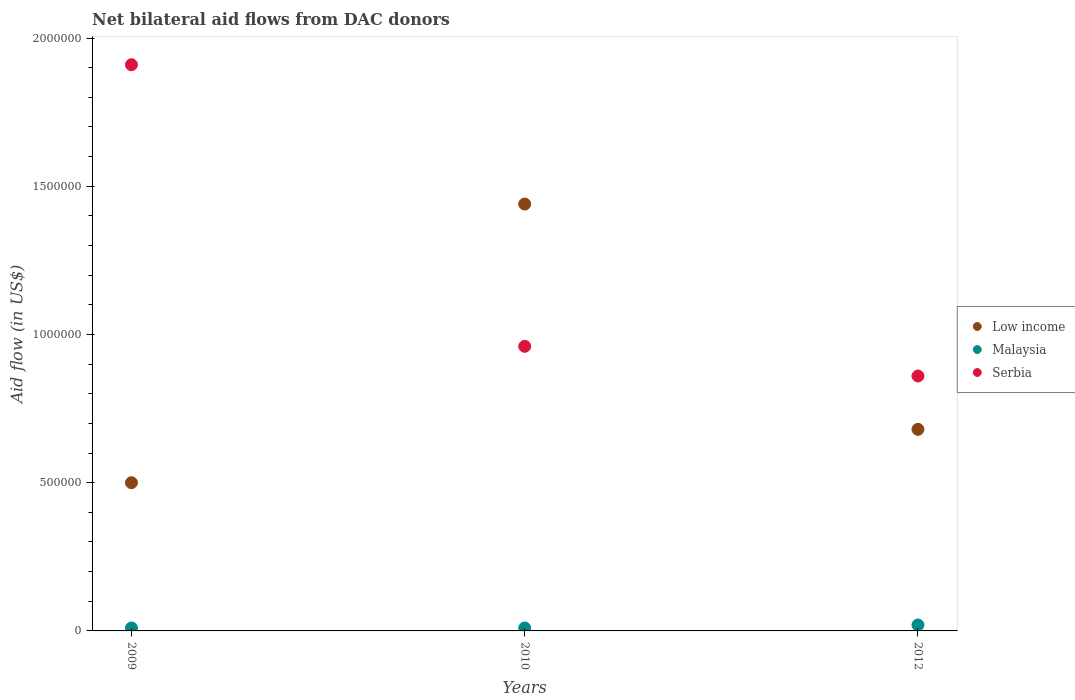Is the number of dotlines equal to the number of legend labels?
Your response must be concise. Yes. Across all years, what is the maximum net bilateral aid flow in Low income?
Your answer should be very brief. 1.44e+06. Across all years, what is the minimum net bilateral aid flow in Low income?
Give a very brief answer. 5.00e+05. In which year was the net bilateral aid flow in Serbia minimum?
Provide a succinct answer. 2012. What is the total net bilateral aid flow in Low income in the graph?
Offer a terse response. 2.62e+06. What is the difference between the net bilateral aid flow in Malaysia in 2010 and that in 2012?
Provide a succinct answer. -10000. What is the difference between the net bilateral aid flow in Serbia in 2009 and the net bilateral aid flow in Low income in 2010?
Your response must be concise. 4.70e+05. What is the average net bilateral aid flow in Serbia per year?
Offer a terse response. 1.24e+06. In the year 2010, what is the difference between the net bilateral aid flow in Low income and net bilateral aid flow in Malaysia?
Make the answer very short. 1.43e+06. In how many years, is the net bilateral aid flow in Low income greater than 1200000 US$?
Ensure brevity in your answer.  1. What is the ratio of the net bilateral aid flow in Serbia in 2010 to that in 2012?
Offer a terse response. 1.12. What is the difference between the highest and the lowest net bilateral aid flow in Serbia?
Offer a terse response. 1.05e+06. Is the net bilateral aid flow in Malaysia strictly greater than the net bilateral aid flow in Serbia over the years?
Give a very brief answer. No. Does the graph contain any zero values?
Your answer should be compact. No. How are the legend labels stacked?
Offer a terse response. Vertical. What is the title of the graph?
Your response must be concise. Net bilateral aid flows from DAC donors. Does "Bahrain" appear as one of the legend labels in the graph?
Provide a short and direct response. No. What is the label or title of the Y-axis?
Make the answer very short. Aid flow (in US$). What is the Aid flow (in US$) of Malaysia in 2009?
Your answer should be very brief. 10000. What is the Aid flow (in US$) of Serbia in 2009?
Make the answer very short. 1.91e+06. What is the Aid flow (in US$) of Low income in 2010?
Your answer should be very brief. 1.44e+06. What is the Aid flow (in US$) of Serbia in 2010?
Make the answer very short. 9.60e+05. What is the Aid flow (in US$) of Low income in 2012?
Make the answer very short. 6.80e+05. What is the Aid flow (in US$) in Malaysia in 2012?
Ensure brevity in your answer.  2.00e+04. What is the Aid flow (in US$) of Serbia in 2012?
Your answer should be compact. 8.60e+05. Across all years, what is the maximum Aid flow (in US$) in Low income?
Offer a terse response. 1.44e+06. Across all years, what is the maximum Aid flow (in US$) in Serbia?
Provide a short and direct response. 1.91e+06. Across all years, what is the minimum Aid flow (in US$) in Low income?
Ensure brevity in your answer.  5.00e+05. Across all years, what is the minimum Aid flow (in US$) in Malaysia?
Make the answer very short. 10000. Across all years, what is the minimum Aid flow (in US$) in Serbia?
Make the answer very short. 8.60e+05. What is the total Aid flow (in US$) in Low income in the graph?
Provide a succinct answer. 2.62e+06. What is the total Aid flow (in US$) of Malaysia in the graph?
Provide a short and direct response. 4.00e+04. What is the total Aid flow (in US$) of Serbia in the graph?
Offer a very short reply. 3.73e+06. What is the difference between the Aid flow (in US$) of Low income in 2009 and that in 2010?
Keep it short and to the point. -9.40e+05. What is the difference between the Aid flow (in US$) in Serbia in 2009 and that in 2010?
Offer a very short reply. 9.50e+05. What is the difference between the Aid flow (in US$) of Malaysia in 2009 and that in 2012?
Provide a succinct answer. -10000. What is the difference between the Aid flow (in US$) in Serbia in 2009 and that in 2012?
Your answer should be very brief. 1.05e+06. What is the difference between the Aid flow (in US$) of Low income in 2010 and that in 2012?
Provide a short and direct response. 7.60e+05. What is the difference between the Aid flow (in US$) of Low income in 2009 and the Aid flow (in US$) of Serbia in 2010?
Give a very brief answer. -4.60e+05. What is the difference between the Aid flow (in US$) of Malaysia in 2009 and the Aid flow (in US$) of Serbia in 2010?
Keep it short and to the point. -9.50e+05. What is the difference between the Aid flow (in US$) in Low income in 2009 and the Aid flow (in US$) in Malaysia in 2012?
Provide a succinct answer. 4.80e+05. What is the difference between the Aid flow (in US$) of Low income in 2009 and the Aid flow (in US$) of Serbia in 2012?
Your answer should be very brief. -3.60e+05. What is the difference between the Aid flow (in US$) in Malaysia in 2009 and the Aid flow (in US$) in Serbia in 2012?
Your response must be concise. -8.50e+05. What is the difference between the Aid flow (in US$) of Low income in 2010 and the Aid flow (in US$) of Malaysia in 2012?
Offer a terse response. 1.42e+06. What is the difference between the Aid flow (in US$) of Low income in 2010 and the Aid flow (in US$) of Serbia in 2012?
Give a very brief answer. 5.80e+05. What is the difference between the Aid flow (in US$) of Malaysia in 2010 and the Aid flow (in US$) of Serbia in 2012?
Offer a very short reply. -8.50e+05. What is the average Aid flow (in US$) in Low income per year?
Offer a terse response. 8.73e+05. What is the average Aid flow (in US$) of Malaysia per year?
Offer a terse response. 1.33e+04. What is the average Aid flow (in US$) in Serbia per year?
Make the answer very short. 1.24e+06. In the year 2009, what is the difference between the Aid flow (in US$) of Low income and Aid flow (in US$) of Serbia?
Your response must be concise. -1.41e+06. In the year 2009, what is the difference between the Aid flow (in US$) in Malaysia and Aid flow (in US$) in Serbia?
Make the answer very short. -1.90e+06. In the year 2010, what is the difference between the Aid flow (in US$) in Low income and Aid flow (in US$) in Malaysia?
Provide a short and direct response. 1.43e+06. In the year 2010, what is the difference between the Aid flow (in US$) of Low income and Aid flow (in US$) of Serbia?
Make the answer very short. 4.80e+05. In the year 2010, what is the difference between the Aid flow (in US$) of Malaysia and Aid flow (in US$) of Serbia?
Your answer should be compact. -9.50e+05. In the year 2012, what is the difference between the Aid flow (in US$) in Low income and Aid flow (in US$) in Serbia?
Your response must be concise. -1.80e+05. In the year 2012, what is the difference between the Aid flow (in US$) of Malaysia and Aid flow (in US$) of Serbia?
Ensure brevity in your answer.  -8.40e+05. What is the ratio of the Aid flow (in US$) in Low income in 2009 to that in 2010?
Give a very brief answer. 0.35. What is the ratio of the Aid flow (in US$) in Serbia in 2009 to that in 2010?
Your answer should be very brief. 1.99. What is the ratio of the Aid flow (in US$) in Low income in 2009 to that in 2012?
Your answer should be very brief. 0.74. What is the ratio of the Aid flow (in US$) of Malaysia in 2009 to that in 2012?
Provide a short and direct response. 0.5. What is the ratio of the Aid flow (in US$) of Serbia in 2009 to that in 2012?
Keep it short and to the point. 2.22. What is the ratio of the Aid flow (in US$) in Low income in 2010 to that in 2012?
Your answer should be compact. 2.12. What is the ratio of the Aid flow (in US$) in Malaysia in 2010 to that in 2012?
Provide a succinct answer. 0.5. What is the ratio of the Aid flow (in US$) in Serbia in 2010 to that in 2012?
Make the answer very short. 1.12. What is the difference between the highest and the second highest Aid flow (in US$) in Low income?
Offer a terse response. 7.60e+05. What is the difference between the highest and the second highest Aid flow (in US$) in Malaysia?
Your answer should be very brief. 10000. What is the difference between the highest and the second highest Aid flow (in US$) of Serbia?
Provide a succinct answer. 9.50e+05. What is the difference between the highest and the lowest Aid flow (in US$) in Low income?
Offer a terse response. 9.40e+05. What is the difference between the highest and the lowest Aid flow (in US$) of Serbia?
Ensure brevity in your answer.  1.05e+06. 